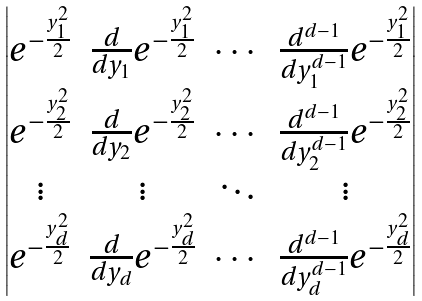<formula> <loc_0><loc_0><loc_500><loc_500>\begin{vmatrix} e ^ { - \frac { y _ { 1 } ^ { 2 } } { 2 } } & \frac { d } { d y _ { 1 } } e ^ { - \frac { y _ { 1 } ^ { 2 } } { 2 } } & \cdots & \frac { d ^ { d - 1 } } { d y _ { 1 } ^ { d - 1 } } e ^ { - \frac { y _ { 1 } ^ { 2 } } { 2 } } \\ e ^ { - \frac { y _ { 2 } ^ { 2 } } { 2 } } & \frac { d } { d y _ { 2 } } e ^ { - \frac { y _ { 2 } ^ { 2 } } { 2 } } & \cdots & \frac { d ^ { d - 1 } } { d y _ { 2 } ^ { d - 1 } } e ^ { - \frac { y _ { 2 } ^ { 2 } } { 2 } } \\ \vdots & \vdots & \ddots & \vdots \\ e ^ { - \frac { y _ { d } ^ { 2 } } { 2 } } & \frac { d } { d y _ { d } } e ^ { - \frac { y _ { d } ^ { 2 } } { 2 } } & \cdots & \frac { d ^ { d - 1 } } { d y _ { d } ^ { d - 1 } } e ^ { - \frac { y _ { d } ^ { 2 } } { 2 } } \end{vmatrix}</formula> 